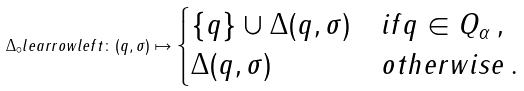<formula> <loc_0><loc_0><loc_500><loc_500>\Delta _ { \circ } l e a r r o w l e f t \colon ( q , \sigma ) \mapsto \begin{cases} \{ q \} \cup \Delta ( q , \sigma ) & i f q \in Q _ { \alpha } \, , \\ \Delta ( q , \sigma ) & o t h e r w i s e \, . \end{cases}</formula> 